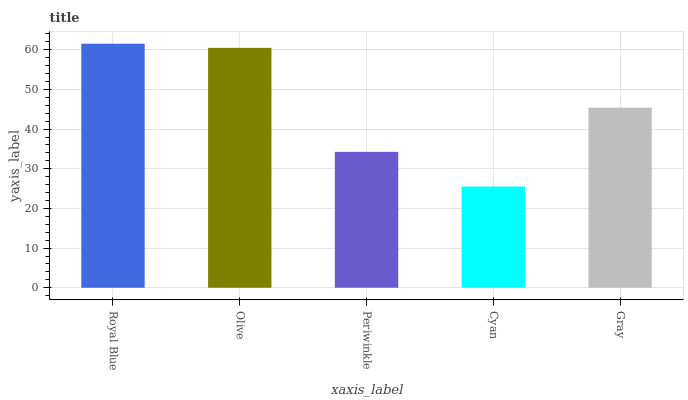Is Cyan the minimum?
Answer yes or no. Yes. Is Royal Blue the maximum?
Answer yes or no. Yes. Is Olive the minimum?
Answer yes or no. No. Is Olive the maximum?
Answer yes or no. No. Is Royal Blue greater than Olive?
Answer yes or no. Yes. Is Olive less than Royal Blue?
Answer yes or no. Yes. Is Olive greater than Royal Blue?
Answer yes or no. No. Is Royal Blue less than Olive?
Answer yes or no. No. Is Gray the high median?
Answer yes or no. Yes. Is Gray the low median?
Answer yes or no. Yes. Is Cyan the high median?
Answer yes or no. No. Is Olive the low median?
Answer yes or no. No. 